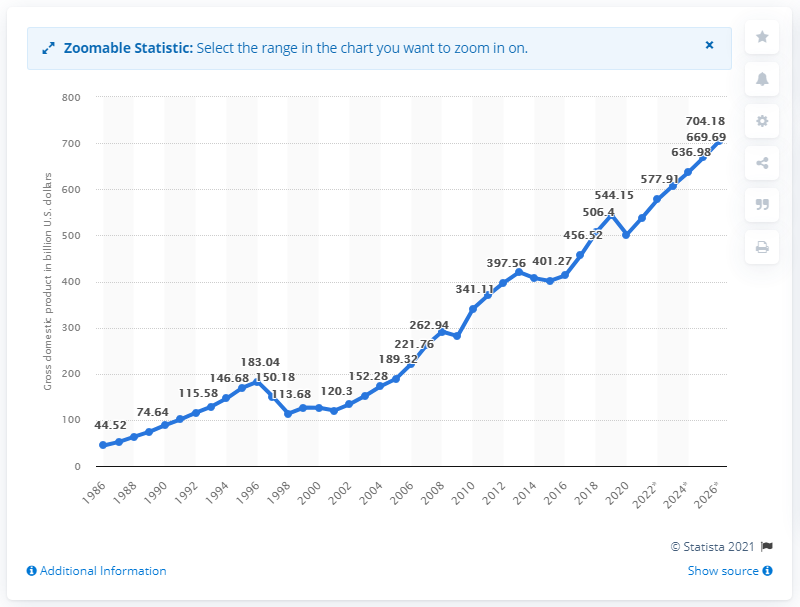Specify some key components in this picture. In 2020, Thailand's gross domestic product was approximately 501.89 billion dollars. 